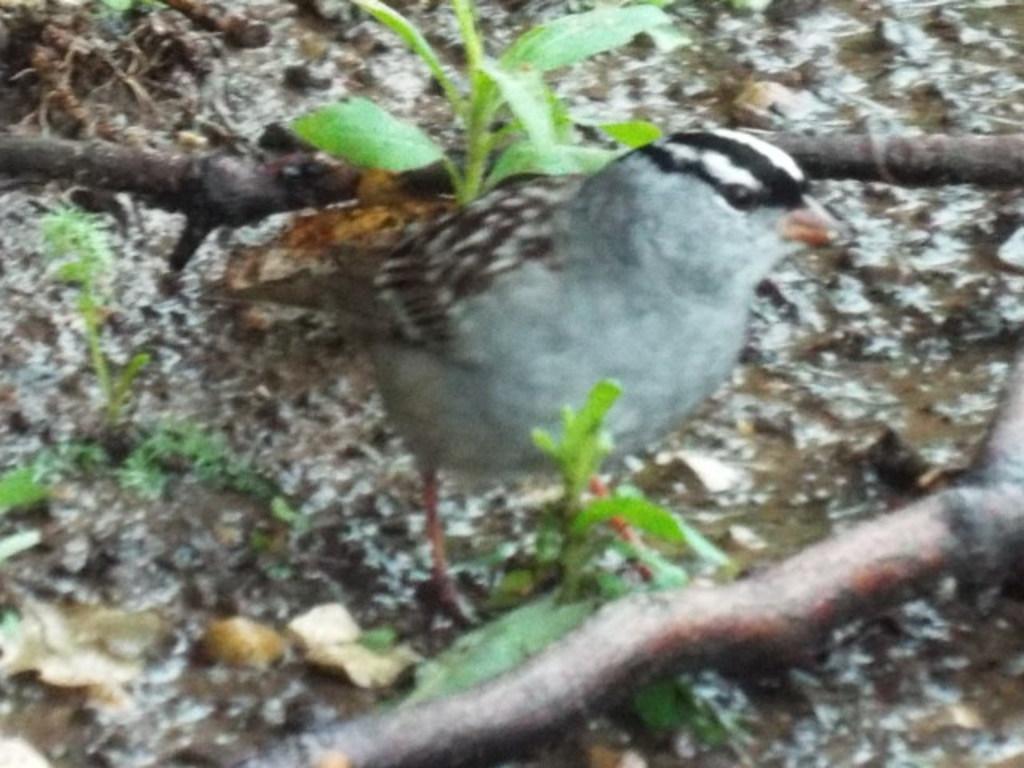In one or two sentences, can you explain what this image depicts? In the center of the image there is a bird. There are plants and twigs. 